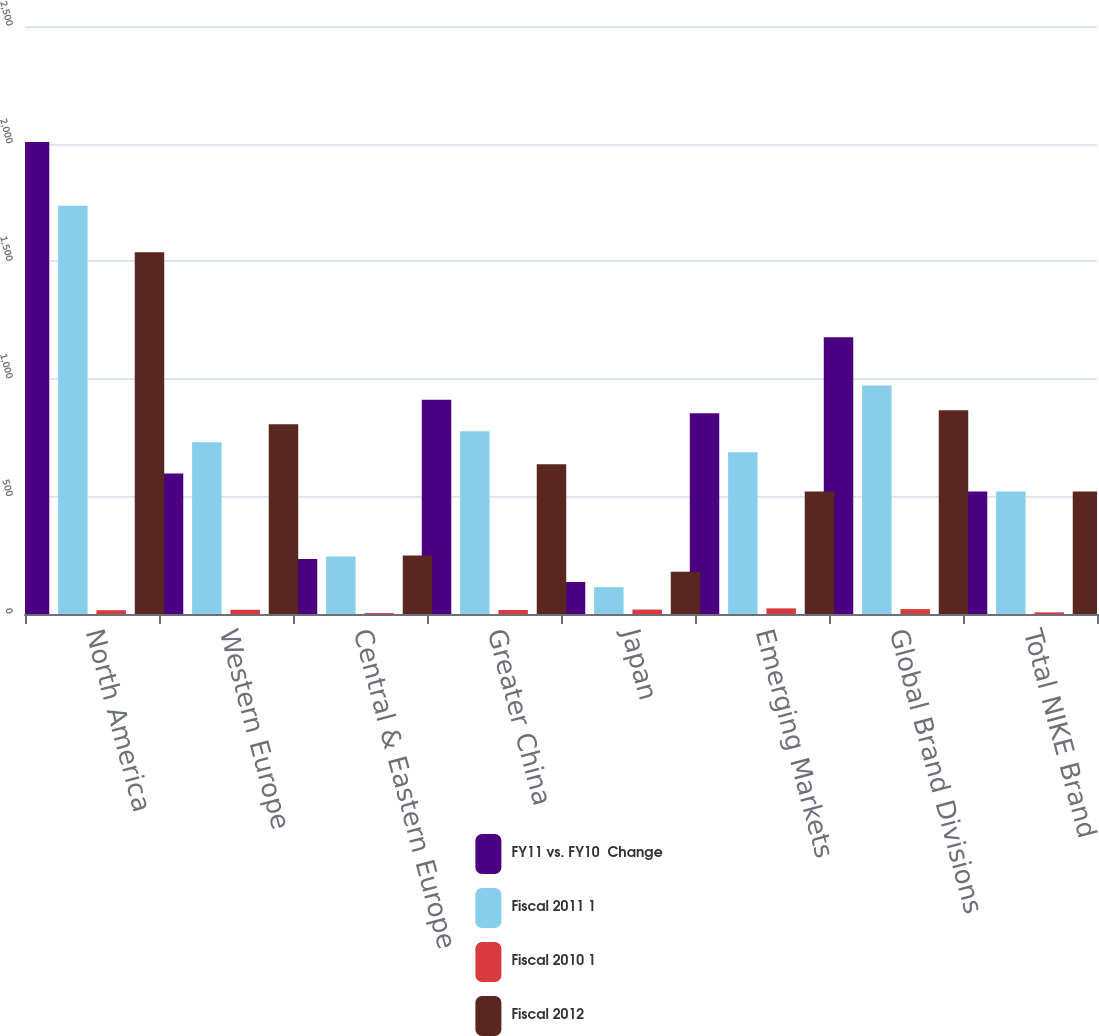<chart> <loc_0><loc_0><loc_500><loc_500><stacked_bar_chart><ecel><fcel>North America<fcel>Western Europe<fcel>Central & Eastern Europe<fcel>Greater China<fcel>Japan<fcel>Emerging Markets<fcel>Global Brand Divisions<fcel>Total NIKE Brand<nl><fcel>FY11 vs. FY10  Change<fcel>2007<fcel>597<fcel>234<fcel>911<fcel>136<fcel>853<fcel>1177<fcel>521<nl><fcel>Fiscal 2011 1<fcel>1736<fcel>730<fcel>244<fcel>777<fcel>114<fcel>688<fcel>971<fcel>521<nl><fcel>Fiscal 2010 1<fcel>16<fcel>18<fcel>4<fcel>17<fcel>19<fcel>24<fcel>21<fcel>7<nl><fcel>Fiscal 2012<fcel>1538<fcel>807<fcel>249<fcel>637<fcel>180<fcel>521<fcel>866<fcel>521<nl></chart> 